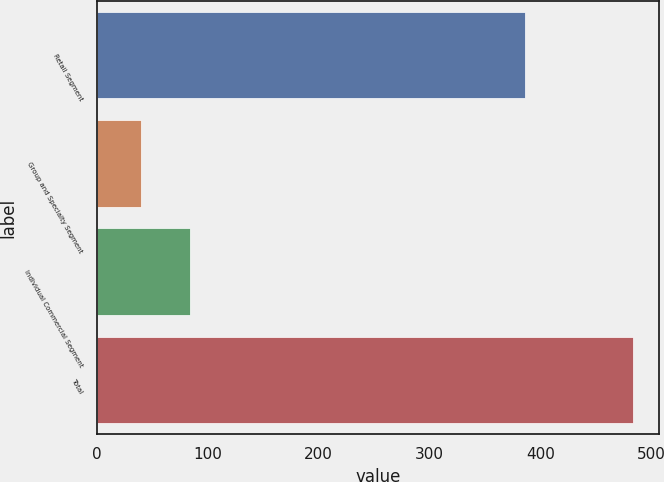Convert chart. <chart><loc_0><loc_0><loc_500><loc_500><bar_chart><fcel>Retail Segment<fcel>Group and Specialty Segment<fcel>Individual Commercial Segment<fcel>Total<nl><fcel>386<fcel>40<fcel>84.3<fcel>483<nl></chart> 